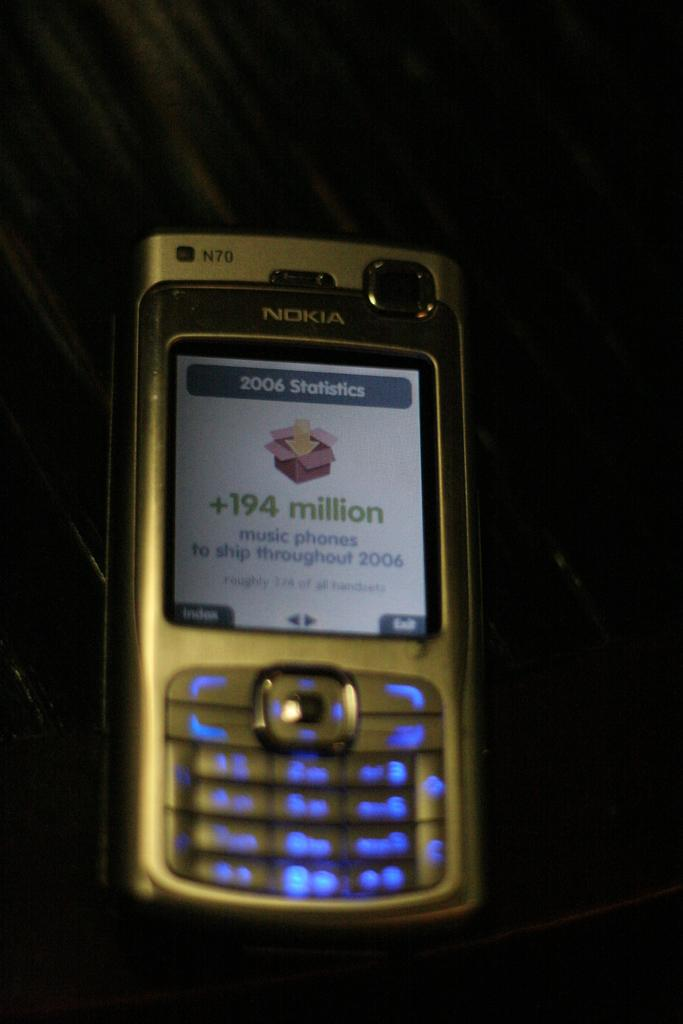What electronic device is visible in the image? There is a mobile phone in the image. What features are present on the mobile phone? The mobile phone has buttons and a screen. What is displayed on the screen of the mobile phone? There is text written on the screen. What is the background color in the image? The background color is black. What type of paper is being used to create the base of the mobile phone in the image? There is: There is no paper or base mentioned in the image; it features a mobile phone with buttons, a screen, and text displayed on the screen. 